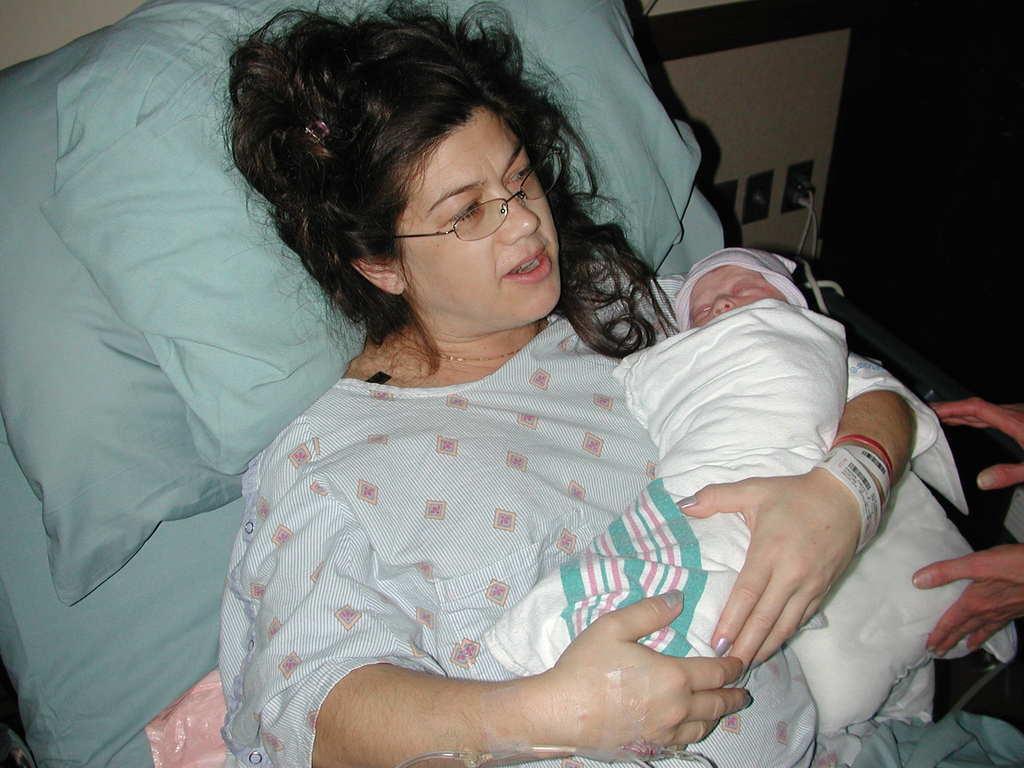In one or two sentences, can you explain what this image depicts? There is a woman on the bed and there is a baby in her hands and there's another person in the right corner 